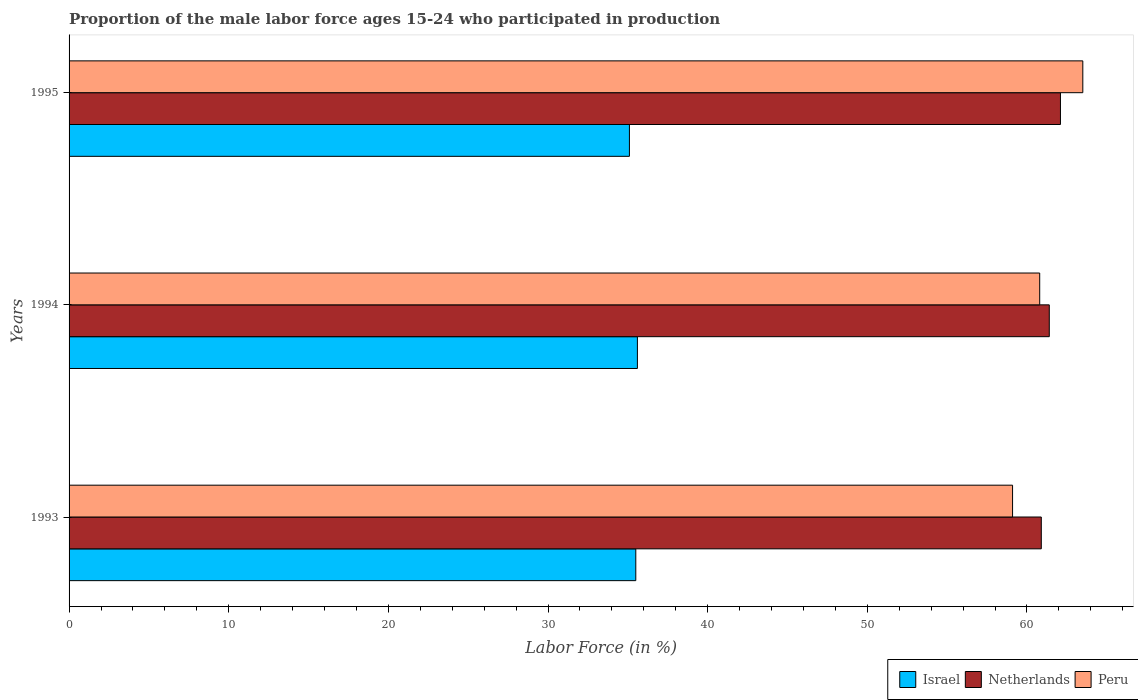Are the number of bars on each tick of the Y-axis equal?
Offer a very short reply. Yes. What is the label of the 2nd group of bars from the top?
Your answer should be very brief. 1994. In how many cases, is the number of bars for a given year not equal to the number of legend labels?
Your answer should be compact. 0. What is the proportion of the male labor force who participated in production in Peru in 1995?
Provide a succinct answer. 63.5. Across all years, what is the maximum proportion of the male labor force who participated in production in Netherlands?
Make the answer very short. 62.1. Across all years, what is the minimum proportion of the male labor force who participated in production in Israel?
Make the answer very short. 35.1. In which year was the proportion of the male labor force who participated in production in Israel minimum?
Offer a very short reply. 1995. What is the total proportion of the male labor force who participated in production in Netherlands in the graph?
Keep it short and to the point. 184.4. What is the difference between the proportion of the male labor force who participated in production in Netherlands in 1993 and that in 1995?
Provide a succinct answer. -1.2. What is the difference between the proportion of the male labor force who participated in production in Peru in 1994 and the proportion of the male labor force who participated in production in Netherlands in 1995?
Offer a very short reply. -1.3. What is the average proportion of the male labor force who participated in production in Peru per year?
Your answer should be very brief. 61.13. In the year 1993, what is the difference between the proportion of the male labor force who participated in production in Peru and proportion of the male labor force who participated in production in Israel?
Give a very brief answer. 23.6. What is the ratio of the proportion of the male labor force who participated in production in Netherlands in 1993 to that in 1994?
Give a very brief answer. 0.99. Is the proportion of the male labor force who participated in production in Israel in 1993 less than that in 1994?
Your response must be concise. Yes. Is the difference between the proportion of the male labor force who participated in production in Peru in 1993 and 1994 greater than the difference between the proportion of the male labor force who participated in production in Israel in 1993 and 1994?
Your answer should be compact. No. What is the difference between the highest and the second highest proportion of the male labor force who participated in production in Peru?
Make the answer very short. 2.7. What is the difference between the highest and the lowest proportion of the male labor force who participated in production in Netherlands?
Provide a succinct answer. 1.2. Is the sum of the proportion of the male labor force who participated in production in Netherlands in 1994 and 1995 greater than the maximum proportion of the male labor force who participated in production in Peru across all years?
Keep it short and to the point. Yes. What does the 3rd bar from the top in 1995 represents?
Ensure brevity in your answer.  Israel. What does the 1st bar from the bottom in 1993 represents?
Ensure brevity in your answer.  Israel. Is it the case that in every year, the sum of the proportion of the male labor force who participated in production in Israel and proportion of the male labor force who participated in production in Netherlands is greater than the proportion of the male labor force who participated in production in Peru?
Your response must be concise. Yes. Are the values on the major ticks of X-axis written in scientific E-notation?
Your answer should be compact. No. Does the graph contain any zero values?
Provide a succinct answer. No. Does the graph contain grids?
Your response must be concise. No. Where does the legend appear in the graph?
Your answer should be very brief. Bottom right. How many legend labels are there?
Your response must be concise. 3. How are the legend labels stacked?
Give a very brief answer. Horizontal. What is the title of the graph?
Your response must be concise. Proportion of the male labor force ages 15-24 who participated in production. What is the Labor Force (in %) in Israel in 1993?
Provide a short and direct response. 35.5. What is the Labor Force (in %) of Netherlands in 1993?
Keep it short and to the point. 60.9. What is the Labor Force (in %) of Peru in 1993?
Give a very brief answer. 59.1. What is the Labor Force (in %) in Israel in 1994?
Offer a terse response. 35.6. What is the Labor Force (in %) in Netherlands in 1994?
Provide a succinct answer. 61.4. What is the Labor Force (in %) in Peru in 1994?
Make the answer very short. 60.8. What is the Labor Force (in %) of Israel in 1995?
Give a very brief answer. 35.1. What is the Labor Force (in %) in Netherlands in 1995?
Give a very brief answer. 62.1. What is the Labor Force (in %) of Peru in 1995?
Make the answer very short. 63.5. Across all years, what is the maximum Labor Force (in %) in Israel?
Make the answer very short. 35.6. Across all years, what is the maximum Labor Force (in %) of Netherlands?
Provide a short and direct response. 62.1. Across all years, what is the maximum Labor Force (in %) of Peru?
Provide a short and direct response. 63.5. Across all years, what is the minimum Labor Force (in %) in Israel?
Make the answer very short. 35.1. Across all years, what is the minimum Labor Force (in %) in Netherlands?
Give a very brief answer. 60.9. Across all years, what is the minimum Labor Force (in %) in Peru?
Provide a succinct answer. 59.1. What is the total Labor Force (in %) in Israel in the graph?
Provide a succinct answer. 106.2. What is the total Labor Force (in %) of Netherlands in the graph?
Make the answer very short. 184.4. What is the total Labor Force (in %) of Peru in the graph?
Offer a very short reply. 183.4. What is the difference between the Labor Force (in %) in Israel in 1993 and that in 1994?
Ensure brevity in your answer.  -0.1. What is the difference between the Labor Force (in %) of Netherlands in 1993 and that in 1994?
Make the answer very short. -0.5. What is the difference between the Labor Force (in %) in Peru in 1993 and that in 1994?
Your answer should be compact. -1.7. What is the difference between the Labor Force (in %) in Netherlands in 1993 and that in 1995?
Ensure brevity in your answer.  -1.2. What is the difference between the Labor Force (in %) of Peru in 1993 and that in 1995?
Ensure brevity in your answer.  -4.4. What is the difference between the Labor Force (in %) in Netherlands in 1994 and that in 1995?
Make the answer very short. -0.7. What is the difference between the Labor Force (in %) in Israel in 1993 and the Labor Force (in %) in Netherlands in 1994?
Give a very brief answer. -25.9. What is the difference between the Labor Force (in %) of Israel in 1993 and the Labor Force (in %) of Peru in 1994?
Ensure brevity in your answer.  -25.3. What is the difference between the Labor Force (in %) in Israel in 1993 and the Labor Force (in %) in Netherlands in 1995?
Make the answer very short. -26.6. What is the difference between the Labor Force (in %) in Israel in 1993 and the Labor Force (in %) in Peru in 1995?
Offer a very short reply. -28. What is the difference between the Labor Force (in %) in Netherlands in 1993 and the Labor Force (in %) in Peru in 1995?
Provide a short and direct response. -2.6. What is the difference between the Labor Force (in %) of Israel in 1994 and the Labor Force (in %) of Netherlands in 1995?
Your response must be concise. -26.5. What is the difference between the Labor Force (in %) of Israel in 1994 and the Labor Force (in %) of Peru in 1995?
Provide a short and direct response. -27.9. What is the average Labor Force (in %) of Israel per year?
Make the answer very short. 35.4. What is the average Labor Force (in %) in Netherlands per year?
Your answer should be compact. 61.47. What is the average Labor Force (in %) in Peru per year?
Ensure brevity in your answer.  61.13. In the year 1993, what is the difference between the Labor Force (in %) in Israel and Labor Force (in %) in Netherlands?
Your response must be concise. -25.4. In the year 1993, what is the difference between the Labor Force (in %) in Israel and Labor Force (in %) in Peru?
Your answer should be compact. -23.6. In the year 1993, what is the difference between the Labor Force (in %) in Netherlands and Labor Force (in %) in Peru?
Ensure brevity in your answer.  1.8. In the year 1994, what is the difference between the Labor Force (in %) in Israel and Labor Force (in %) in Netherlands?
Your answer should be very brief. -25.8. In the year 1994, what is the difference between the Labor Force (in %) of Israel and Labor Force (in %) of Peru?
Make the answer very short. -25.2. In the year 1994, what is the difference between the Labor Force (in %) of Netherlands and Labor Force (in %) of Peru?
Make the answer very short. 0.6. In the year 1995, what is the difference between the Labor Force (in %) of Israel and Labor Force (in %) of Netherlands?
Your answer should be very brief. -27. In the year 1995, what is the difference between the Labor Force (in %) in Israel and Labor Force (in %) in Peru?
Your answer should be very brief. -28.4. What is the ratio of the Labor Force (in %) in Israel in 1993 to that in 1994?
Provide a succinct answer. 1. What is the ratio of the Labor Force (in %) in Netherlands in 1993 to that in 1994?
Keep it short and to the point. 0.99. What is the ratio of the Labor Force (in %) in Israel in 1993 to that in 1995?
Give a very brief answer. 1.01. What is the ratio of the Labor Force (in %) in Netherlands in 1993 to that in 1995?
Provide a short and direct response. 0.98. What is the ratio of the Labor Force (in %) of Peru in 1993 to that in 1995?
Your answer should be very brief. 0.93. What is the ratio of the Labor Force (in %) of Israel in 1994 to that in 1995?
Offer a terse response. 1.01. What is the ratio of the Labor Force (in %) of Netherlands in 1994 to that in 1995?
Ensure brevity in your answer.  0.99. What is the ratio of the Labor Force (in %) in Peru in 1994 to that in 1995?
Your answer should be compact. 0.96. What is the difference between the highest and the second highest Labor Force (in %) in Israel?
Make the answer very short. 0.1. What is the difference between the highest and the second highest Labor Force (in %) of Netherlands?
Provide a succinct answer. 0.7. What is the difference between the highest and the second highest Labor Force (in %) of Peru?
Provide a short and direct response. 2.7. What is the difference between the highest and the lowest Labor Force (in %) of Peru?
Make the answer very short. 4.4. 